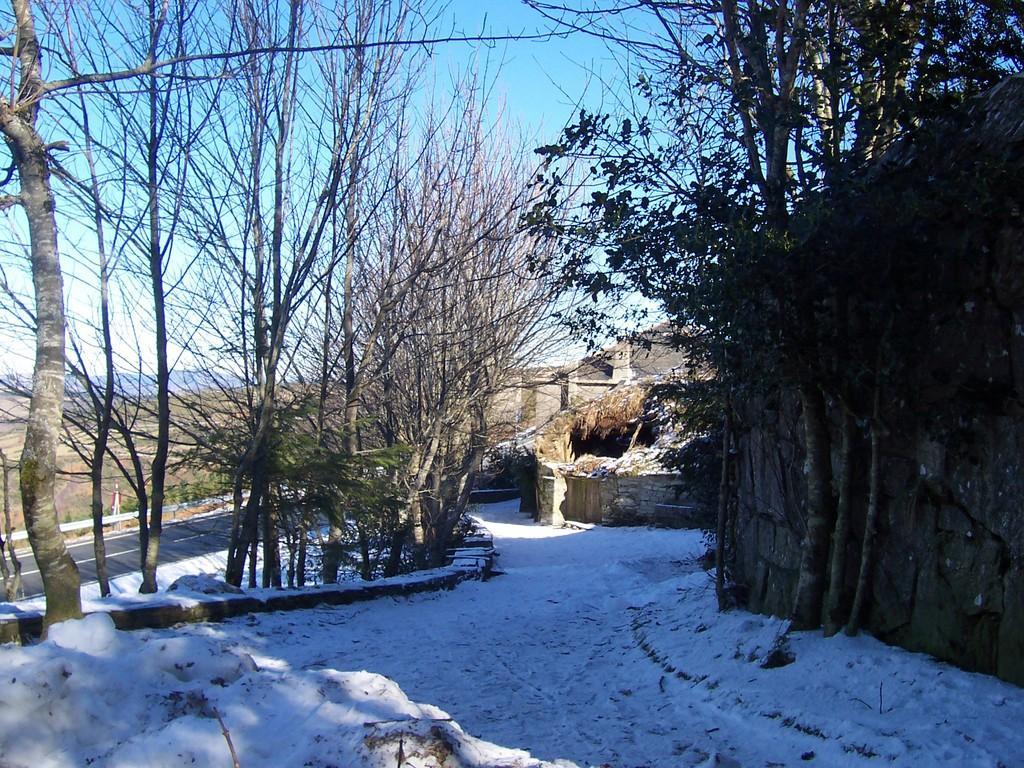In one or two sentences, can you explain what this image depicts? To the bottom of the image on the ground there is a snow. And in the background there are trees and huts with roofs and to the right side there is a roof. And to the top of the image in the background there is a sky. 